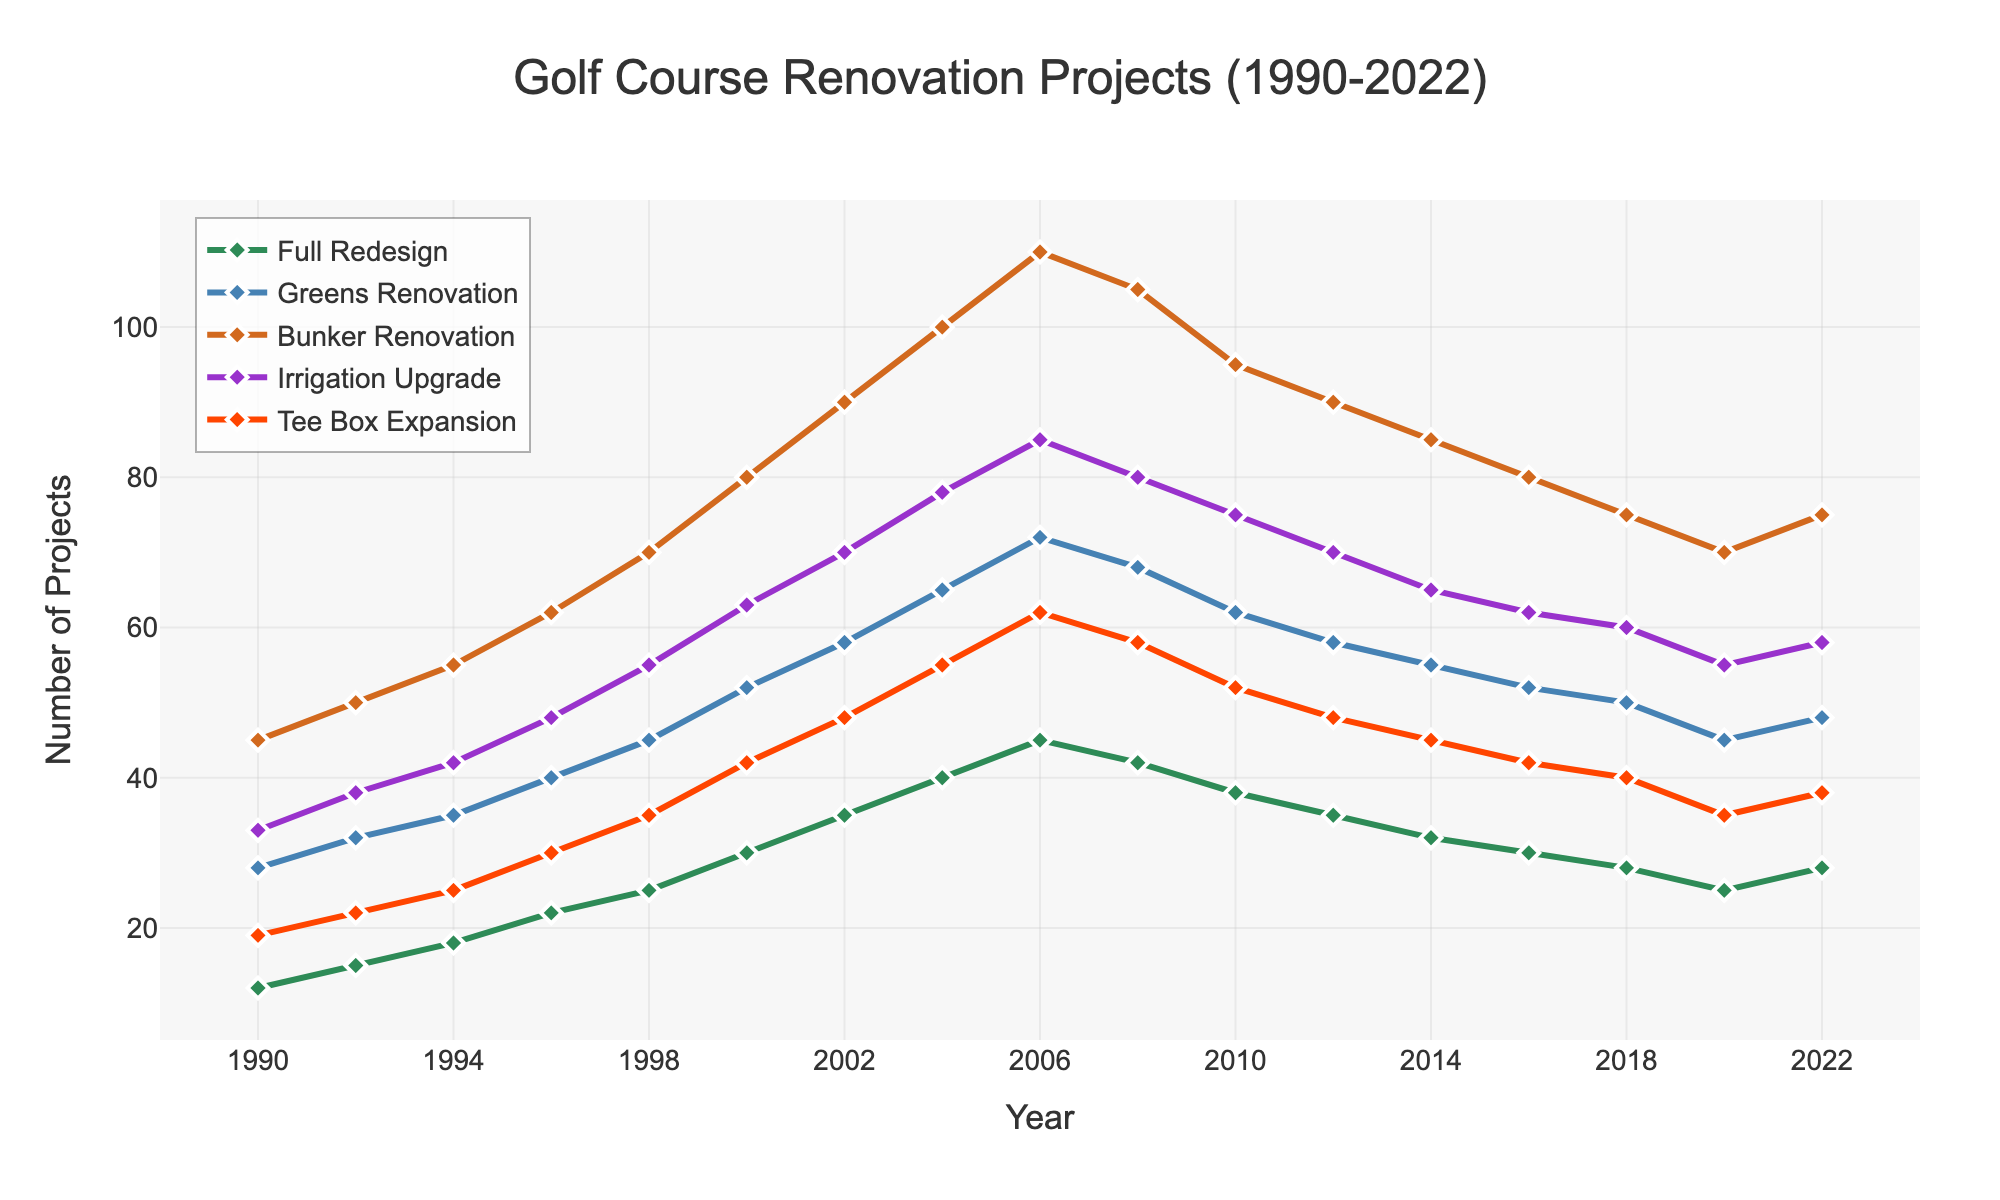What's the trend for "Full Redesign" projects from 1990 to 2022? Look at the line for "Full Redesign" and observe how it changes over time. It generally increases from 1990 to 2006, then shows a decreasing trend from 2008 to 2020, before slightly increasing again in 2022.
Answer: Initially increasing, then decreasing after 2006 Which renovation type had the highest number of projects in 2004? Examine the points for all renovation types in 2004 and identify which one peaks the highest. The "Bunker Renovation" type has the highest number of projects at 100.
Answer: Bunker Renovation In which year did "Greens Renovation" overtake "Full Redesign" in the number of projects? Compare the lines for "Greens Renovation" and "Full Redesign" and see where the former starts to have higher values than the latter. This happens in 2000.
Answer: 2000 How did the number of "Irrigation Upgrade" projects change between 1998 and 2008? Look at the "Irrigation Upgrade" line and compare its value in 1998 and 2008. It increases from 55 in 1998 to 80 in 2008.
Answer: Increased What's the average number of "Tee Box Expansion" projects every year between 1994 and 2000? Sum the values for "Tee Box Expansion" from 1994 (25), 1996 (30), 1998 (35), and 2000 (42) and then divide by the number of years. (25+30+35+42)/4 = 33
Answer: 33 Which renovation type shows the most consistent upward trend from 1990 to 2004? Observe the lines for all renovation types from 1990 to 2004 and see which one steadily increases without much fluctuation. "Full Redesign" shows the most consistent upward trend.
Answer: Full Redesign What is the difference in the number of projects between "Bunker Renovation" and "Irrigation Upgrade" in 2020? Find the values for both "Bunker Renovation" (70) and "Irrigation Upgrade" (55) in 2020 and subtract the latter from the former. 70 - 55 = 15
Answer: 15 In which year was the height of the "Tee Box Expansion" line the lowest after 1990? Look at the points for "Tee Box Expansion" after 1990 and identify the lowest point. The lowest value after 1990 is 40 in 2018.
Answer: 2018 Compare the number of "Full Redesign" projects to "Tee Box Expansion" projects in 2022. Which is higher? Look at the final data points for both "Full Redesign" (28) and "Tee Box Expansion" (38) in 2022. "Tee Box Expansion" has a higher number.
Answer: Tee Box Expansion What's the sum of "Greens Renovation" projects over the years 2004, 2006, and 2008? Add the values for "Greens Renovation" in 2004 (65), 2006 (72), and 2008 (68). 65 + 72 + 68 = 205
Answer: 205 